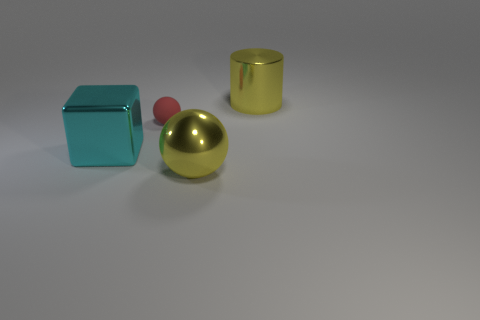Add 1 tiny gray rubber things. How many objects exist? 5 Subtract all cylinders. How many objects are left? 3 Subtract 0 blue cubes. How many objects are left? 4 Subtract all large cyan balls. Subtract all tiny red things. How many objects are left? 3 Add 4 balls. How many balls are left? 6 Add 2 cyan things. How many cyan things exist? 3 